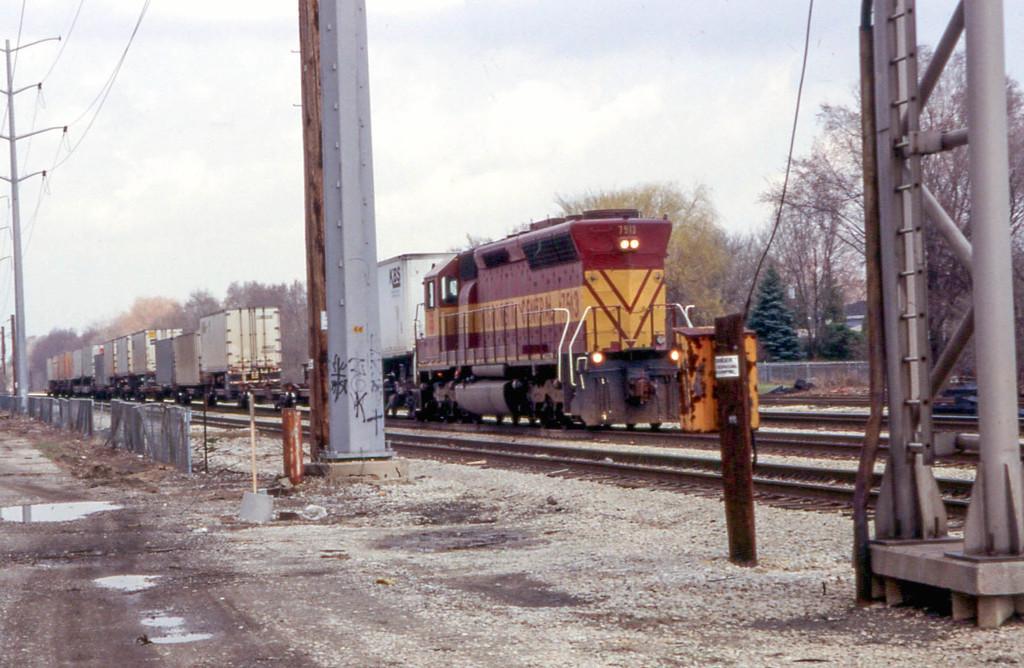Can you describe this image briefly? In this picture we can see a train on the tracks, beside to the train we can find few trees, poles, fence and cables, and also we can see water. 